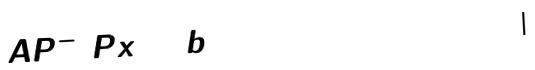Convert formula to latex. <formula><loc_0><loc_0><loc_500><loc_500>A P ^ { - 1 } P x = b</formula> 